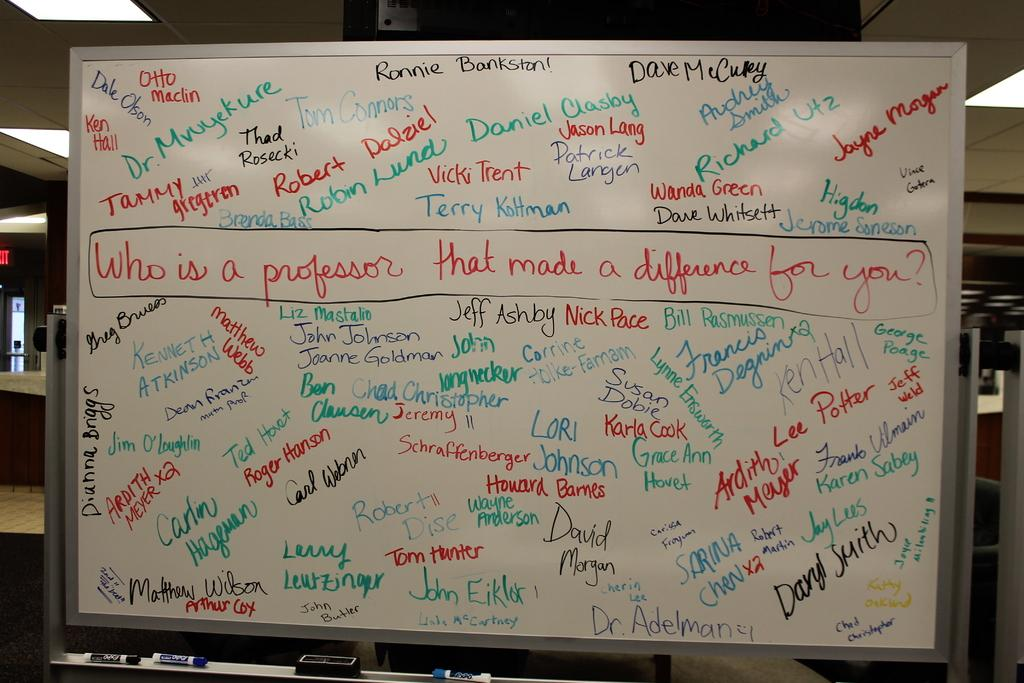<image>
Summarize the visual content of the image. a white board with names and asking Who is a professor 